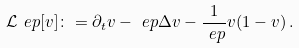Convert formula to latex. <formula><loc_0><loc_0><loc_500><loc_500>\mathcal { L } ^ { \ } e p [ v ] \colon = \partial _ { t } v - \ e p \Delta v - \frac { 1 } { \ e p } v ( 1 - v ) \, .</formula> 